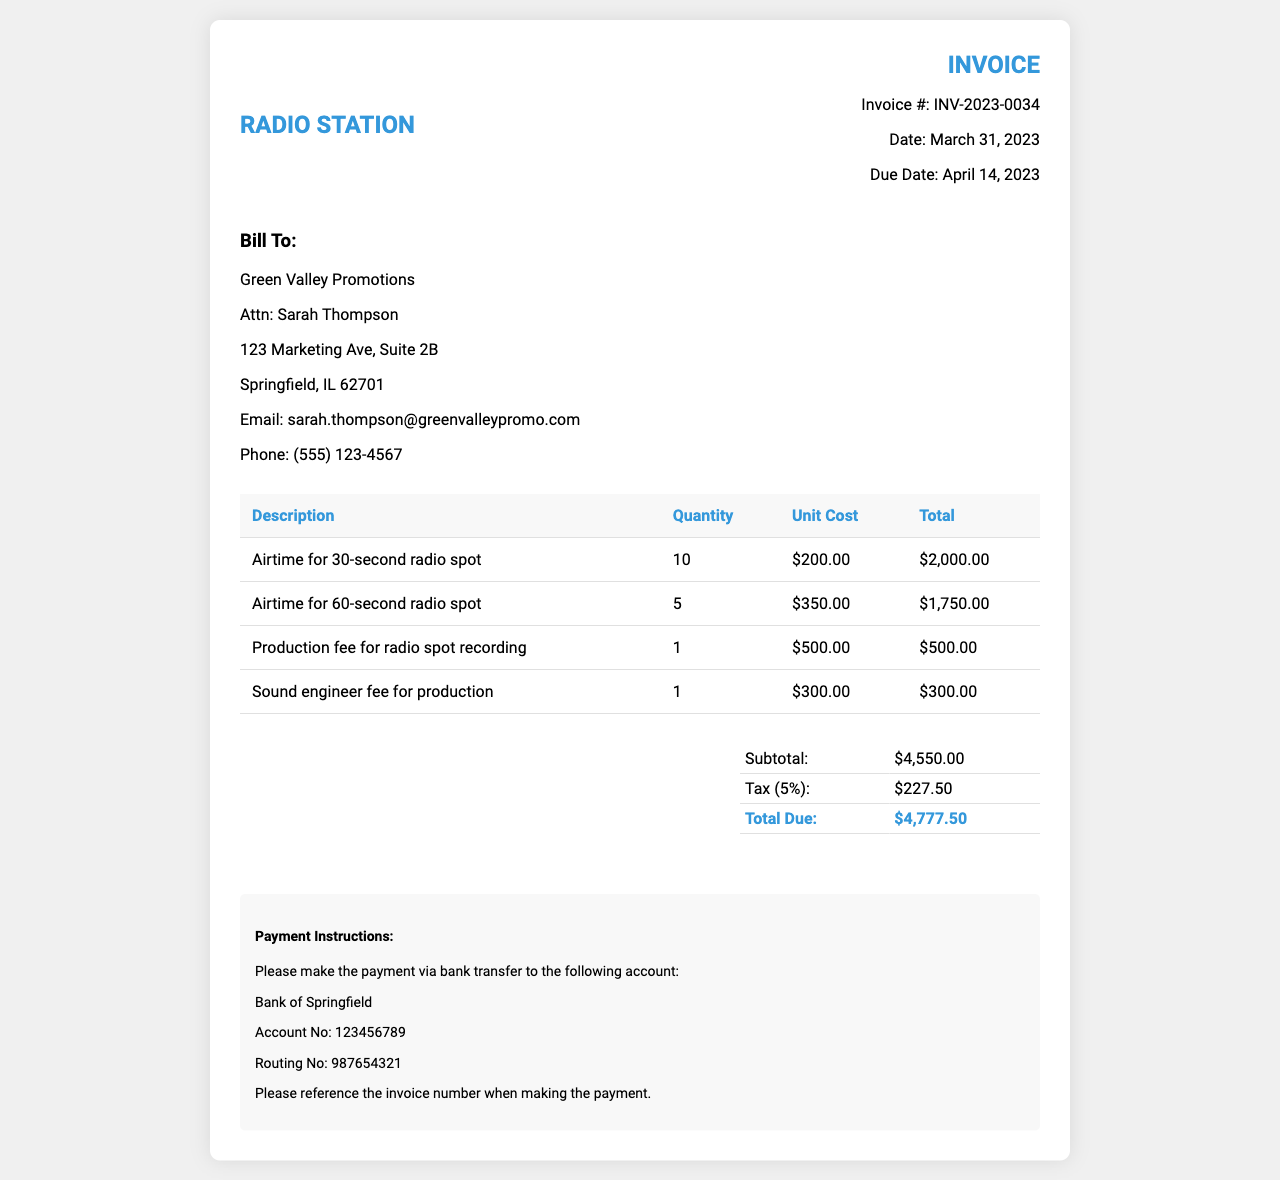What is the invoice number? The invoice number is clearly stated at the top of the document as INV-2023-0034.
Answer: INV-2023-0034 Who is the bill recipient? The document lists Green Valley Promotions as the recipient in the client information section.
Answer: Green Valley Promotions What is the total amount due? The total amount due is calculated at the end of the invoice and listed as $4,777.50.
Answer: $4,777.50 What is the subtotal before tax? The subtotal, which is the sum of itemized costs before tax, is mentioned as $4,550.00.
Answer: $4,550.00 How many 60-second radio spots were billed? The invoice shows that there were 5 charges for the 60-second radio spots in the itemized table.
Answer: 5 What is the production fee for a radio spot recording? The production fee for the radio spot recording is listed as $500.00 in the itemized costs.
Answer: $500.00 When is the due date for the payment? The due date for the payment is specified in the invoice details as April 14, 2023.
Answer: April 14, 2023 What percentage of tax is applied? The invoice indicates a tax rate of 5% applied to the subtotal.
Answer: 5% What is the name of the contact person for the bill recipient? The contact person for Green Valley Promotions is mentioned as Sarah Thompson.
Answer: Sarah Thompson 